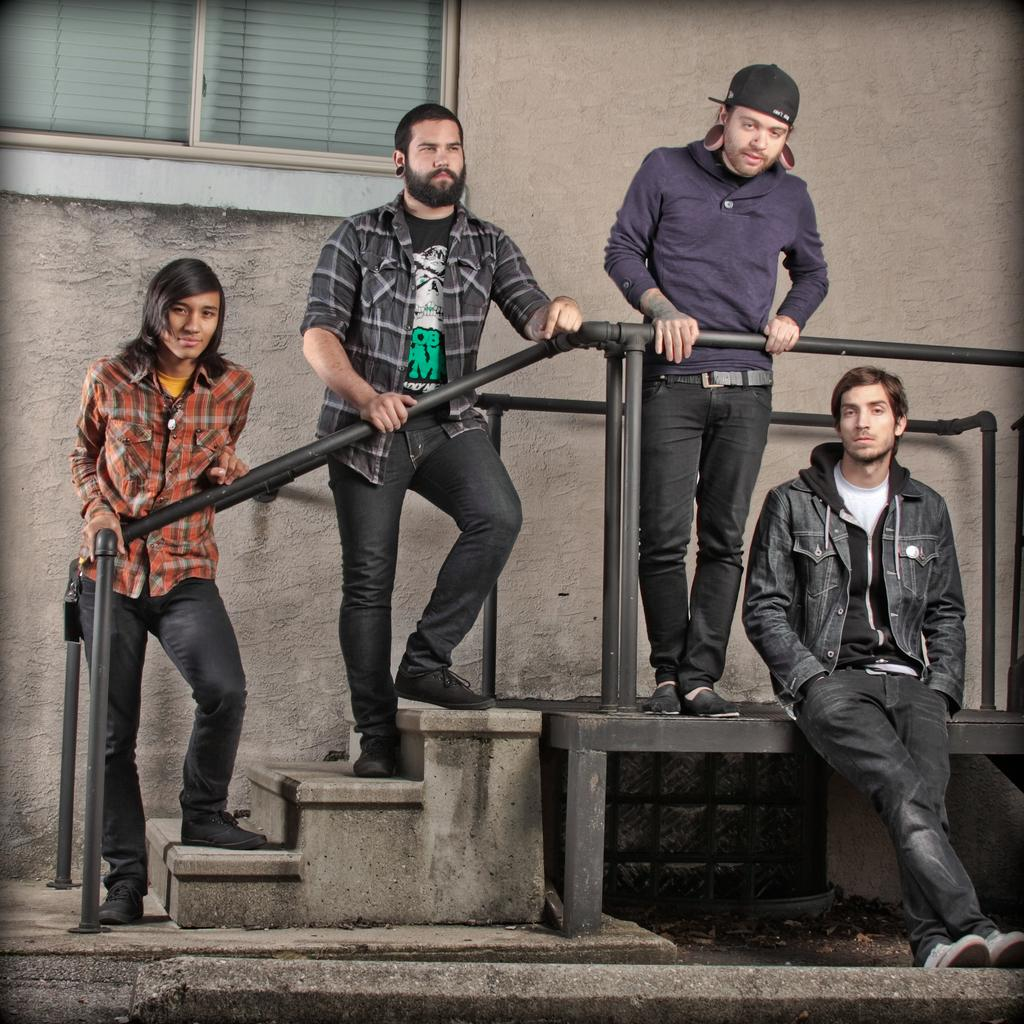How many people are standing on the stairs in the image? There are three people standing on the stairs in the image. What is the position of one person in the image? One person is sitting in the image. What can be seen in the background of the image? There is a building visible in the background of the image. What feature of the building can be observed? The building has glass windows. How can the people be distinguished from each other in the image? The people are wearing different color dresses. Can you see any bears climbing a slope in the image? No, there are no bears or slopes present in the image. 